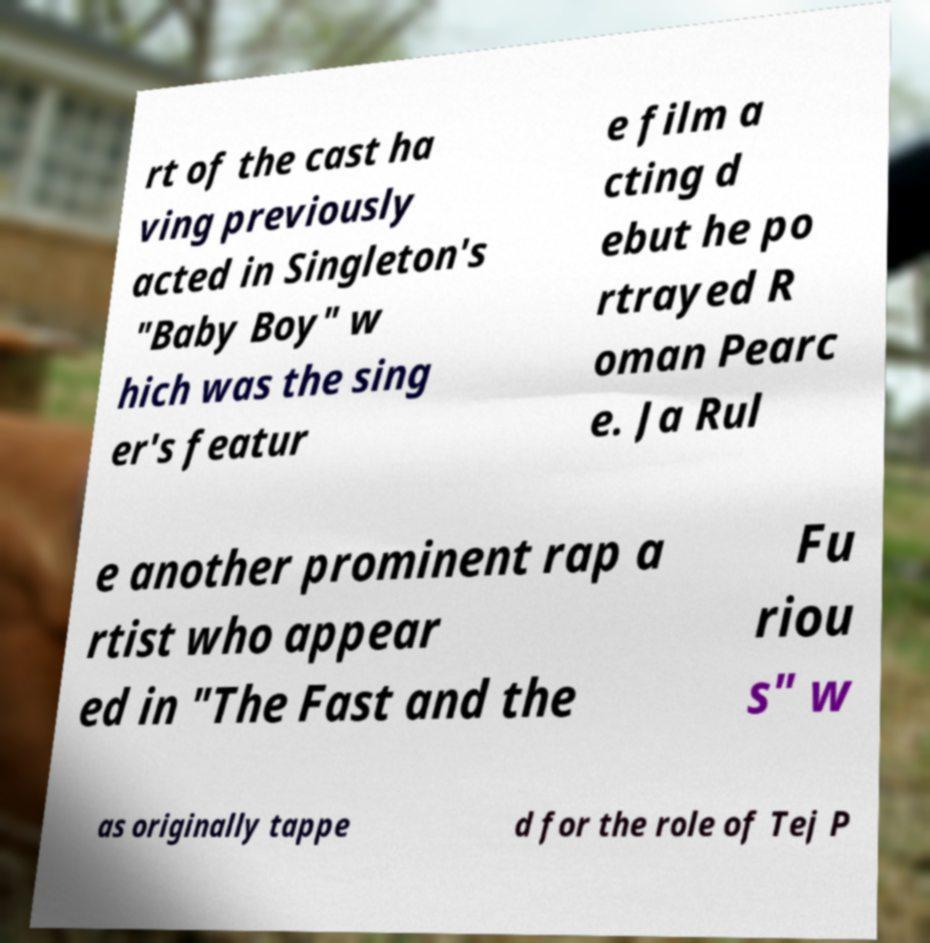Could you assist in decoding the text presented in this image and type it out clearly? rt of the cast ha ving previously acted in Singleton's "Baby Boy" w hich was the sing er's featur e film a cting d ebut he po rtrayed R oman Pearc e. Ja Rul e another prominent rap a rtist who appear ed in "The Fast and the Fu riou s" w as originally tappe d for the role of Tej P 